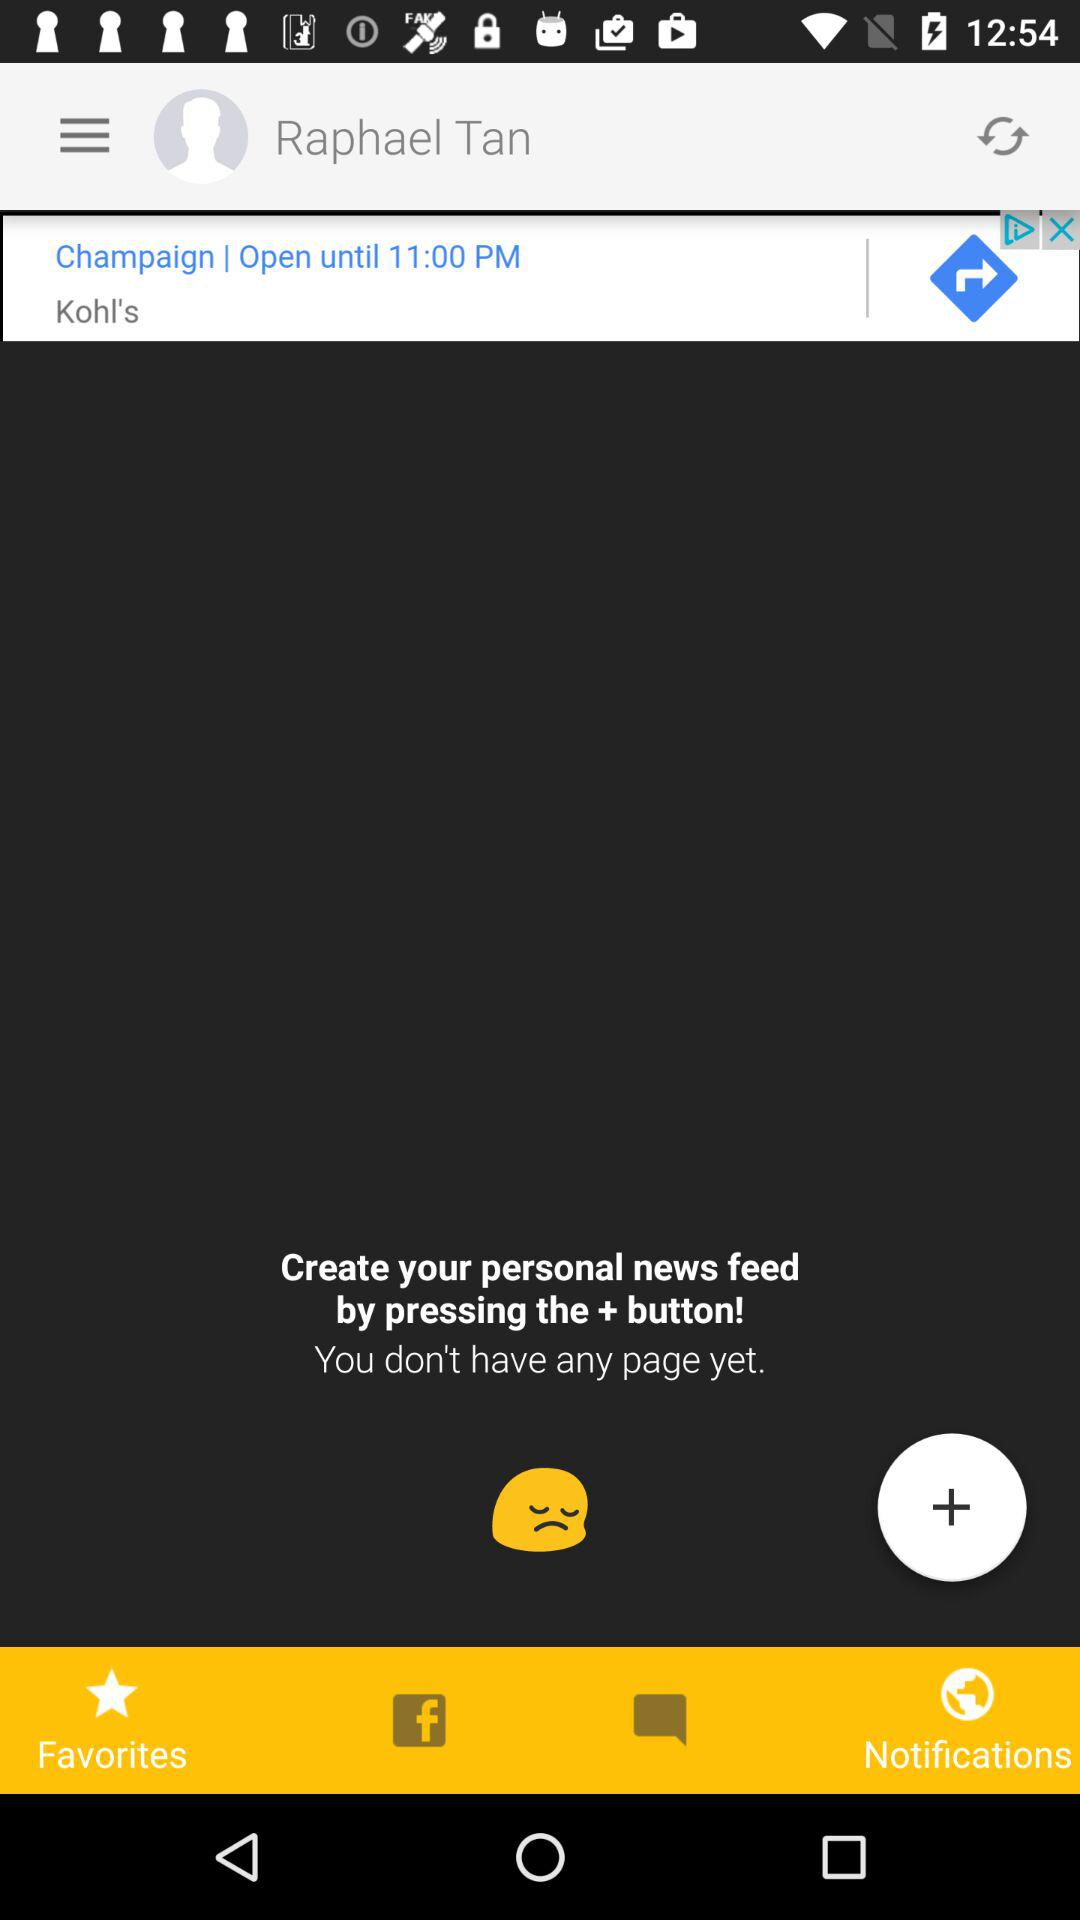How can I create my personal news feed? You can create your personal news feed by pressing the + button. 